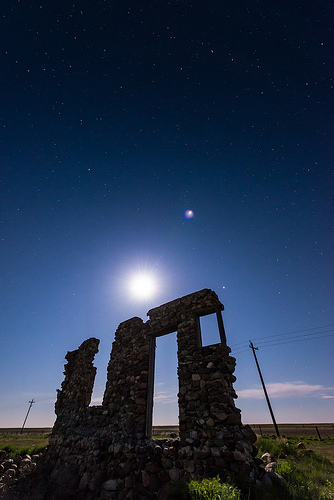<image>
Is the moon in the sky? Yes. The moon is contained within or inside the sky, showing a containment relationship. 